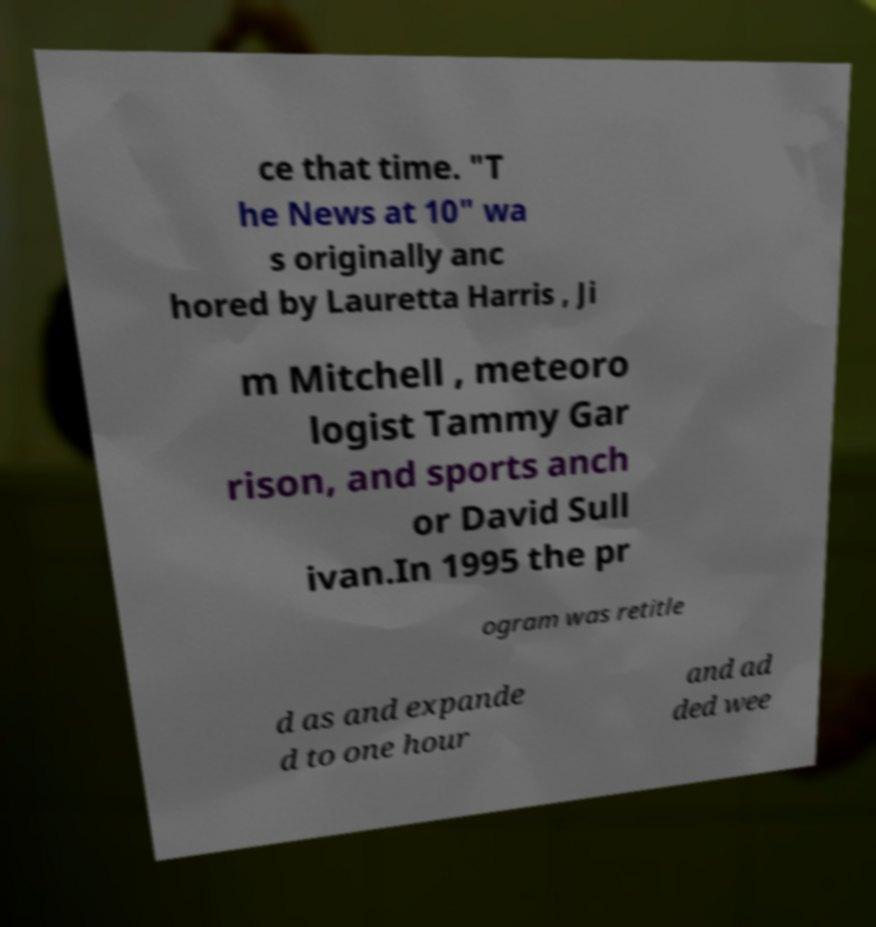For documentation purposes, I need the text within this image transcribed. Could you provide that? ce that time. "T he News at 10" wa s originally anc hored by Lauretta Harris , Ji m Mitchell , meteoro logist Tammy Gar rison, and sports anch or David Sull ivan.In 1995 the pr ogram was retitle d as and expande d to one hour and ad ded wee 